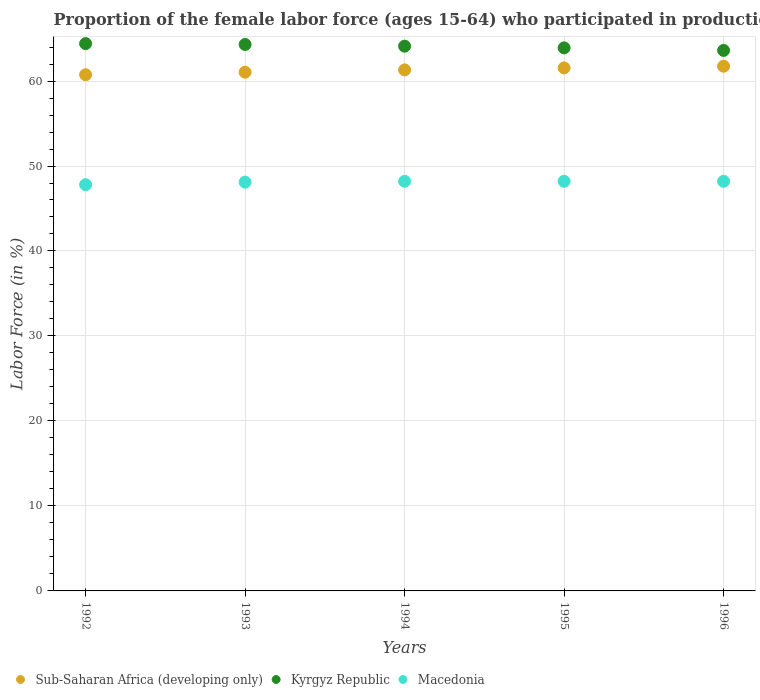What is the proportion of the female labor force who participated in production in Macedonia in 1996?
Keep it short and to the point. 48.2. Across all years, what is the maximum proportion of the female labor force who participated in production in Macedonia?
Offer a very short reply. 48.2. Across all years, what is the minimum proportion of the female labor force who participated in production in Macedonia?
Keep it short and to the point. 47.8. In which year was the proportion of the female labor force who participated in production in Kyrgyz Republic minimum?
Provide a succinct answer. 1996. What is the total proportion of the female labor force who participated in production in Sub-Saharan Africa (developing only) in the graph?
Offer a terse response. 306.37. What is the difference between the proportion of the female labor force who participated in production in Kyrgyz Republic in 1994 and that in 1995?
Make the answer very short. 0.2. What is the difference between the proportion of the female labor force who participated in production in Sub-Saharan Africa (developing only) in 1994 and the proportion of the female labor force who participated in production in Macedonia in 1995?
Keep it short and to the point. 13.11. What is the average proportion of the female labor force who participated in production in Sub-Saharan Africa (developing only) per year?
Provide a succinct answer. 61.27. In the year 1996, what is the difference between the proportion of the female labor force who participated in production in Sub-Saharan Africa (developing only) and proportion of the female labor force who participated in production in Kyrgyz Republic?
Your answer should be very brief. -1.86. What is the ratio of the proportion of the female labor force who participated in production in Kyrgyz Republic in 1994 to that in 1996?
Make the answer very short. 1.01. Is the difference between the proportion of the female labor force who participated in production in Sub-Saharan Africa (developing only) in 1992 and 1993 greater than the difference between the proportion of the female labor force who participated in production in Kyrgyz Republic in 1992 and 1993?
Provide a succinct answer. No. What is the difference between the highest and the second highest proportion of the female labor force who participated in production in Kyrgyz Republic?
Ensure brevity in your answer.  0.1. What is the difference between the highest and the lowest proportion of the female labor force who participated in production in Macedonia?
Keep it short and to the point. 0.4. In how many years, is the proportion of the female labor force who participated in production in Sub-Saharan Africa (developing only) greater than the average proportion of the female labor force who participated in production in Sub-Saharan Africa (developing only) taken over all years?
Your answer should be very brief. 3. Is it the case that in every year, the sum of the proportion of the female labor force who participated in production in Macedonia and proportion of the female labor force who participated in production in Kyrgyz Republic  is greater than the proportion of the female labor force who participated in production in Sub-Saharan Africa (developing only)?
Your response must be concise. Yes. How many years are there in the graph?
Ensure brevity in your answer.  5. What is the difference between two consecutive major ticks on the Y-axis?
Offer a very short reply. 10. Does the graph contain any zero values?
Offer a terse response. No. Where does the legend appear in the graph?
Your answer should be compact. Bottom left. What is the title of the graph?
Your answer should be compact. Proportion of the female labor force (ages 15-64) who participated in production. Does "Vietnam" appear as one of the legend labels in the graph?
Your answer should be compact. No. What is the label or title of the Y-axis?
Make the answer very short. Labor Force (in %). What is the Labor Force (in %) in Sub-Saharan Africa (developing only) in 1992?
Provide a short and direct response. 60.74. What is the Labor Force (in %) of Kyrgyz Republic in 1992?
Make the answer very short. 64.4. What is the Labor Force (in %) in Macedonia in 1992?
Keep it short and to the point. 47.8. What is the Labor Force (in %) in Sub-Saharan Africa (developing only) in 1993?
Your answer should be very brief. 61.04. What is the Labor Force (in %) in Kyrgyz Republic in 1993?
Your response must be concise. 64.3. What is the Labor Force (in %) in Macedonia in 1993?
Make the answer very short. 48.1. What is the Labor Force (in %) of Sub-Saharan Africa (developing only) in 1994?
Provide a succinct answer. 61.31. What is the Labor Force (in %) of Kyrgyz Republic in 1994?
Your answer should be very brief. 64.1. What is the Labor Force (in %) in Macedonia in 1994?
Your answer should be very brief. 48.2. What is the Labor Force (in %) of Sub-Saharan Africa (developing only) in 1995?
Provide a succinct answer. 61.54. What is the Labor Force (in %) in Kyrgyz Republic in 1995?
Your answer should be compact. 63.9. What is the Labor Force (in %) of Macedonia in 1995?
Make the answer very short. 48.2. What is the Labor Force (in %) in Sub-Saharan Africa (developing only) in 1996?
Ensure brevity in your answer.  61.74. What is the Labor Force (in %) of Kyrgyz Republic in 1996?
Offer a terse response. 63.6. What is the Labor Force (in %) in Macedonia in 1996?
Keep it short and to the point. 48.2. Across all years, what is the maximum Labor Force (in %) of Sub-Saharan Africa (developing only)?
Provide a succinct answer. 61.74. Across all years, what is the maximum Labor Force (in %) of Kyrgyz Republic?
Keep it short and to the point. 64.4. Across all years, what is the maximum Labor Force (in %) in Macedonia?
Provide a short and direct response. 48.2. Across all years, what is the minimum Labor Force (in %) of Sub-Saharan Africa (developing only)?
Give a very brief answer. 60.74. Across all years, what is the minimum Labor Force (in %) in Kyrgyz Republic?
Provide a short and direct response. 63.6. Across all years, what is the minimum Labor Force (in %) of Macedonia?
Give a very brief answer. 47.8. What is the total Labor Force (in %) in Sub-Saharan Africa (developing only) in the graph?
Ensure brevity in your answer.  306.37. What is the total Labor Force (in %) in Kyrgyz Republic in the graph?
Your response must be concise. 320.3. What is the total Labor Force (in %) of Macedonia in the graph?
Keep it short and to the point. 240.5. What is the difference between the Labor Force (in %) of Sub-Saharan Africa (developing only) in 1992 and that in 1993?
Give a very brief answer. -0.3. What is the difference between the Labor Force (in %) in Sub-Saharan Africa (developing only) in 1992 and that in 1994?
Provide a short and direct response. -0.57. What is the difference between the Labor Force (in %) of Kyrgyz Republic in 1992 and that in 1994?
Give a very brief answer. 0.3. What is the difference between the Labor Force (in %) of Sub-Saharan Africa (developing only) in 1992 and that in 1995?
Give a very brief answer. -0.8. What is the difference between the Labor Force (in %) in Sub-Saharan Africa (developing only) in 1992 and that in 1996?
Offer a very short reply. -1. What is the difference between the Labor Force (in %) in Macedonia in 1992 and that in 1996?
Your response must be concise. -0.4. What is the difference between the Labor Force (in %) of Sub-Saharan Africa (developing only) in 1993 and that in 1994?
Your response must be concise. -0.27. What is the difference between the Labor Force (in %) in Kyrgyz Republic in 1993 and that in 1994?
Make the answer very short. 0.2. What is the difference between the Labor Force (in %) in Macedonia in 1993 and that in 1994?
Ensure brevity in your answer.  -0.1. What is the difference between the Labor Force (in %) of Sub-Saharan Africa (developing only) in 1993 and that in 1995?
Offer a terse response. -0.5. What is the difference between the Labor Force (in %) in Kyrgyz Republic in 1993 and that in 1995?
Your response must be concise. 0.4. What is the difference between the Labor Force (in %) in Sub-Saharan Africa (developing only) in 1993 and that in 1996?
Give a very brief answer. -0.7. What is the difference between the Labor Force (in %) in Sub-Saharan Africa (developing only) in 1994 and that in 1995?
Your answer should be very brief. -0.23. What is the difference between the Labor Force (in %) in Kyrgyz Republic in 1994 and that in 1995?
Keep it short and to the point. 0.2. What is the difference between the Labor Force (in %) in Macedonia in 1994 and that in 1995?
Your response must be concise. 0. What is the difference between the Labor Force (in %) in Sub-Saharan Africa (developing only) in 1994 and that in 1996?
Make the answer very short. -0.43. What is the difference between the Labor Force (in %) in Kyrgyz Republic in 1994 and that in 1996?
Offer a very short reply. 0.5. What is the difference between the Labor Force (in %) of Macedonia in 1994 and that in 1996?
Give a very brief answer. 0. What is the difference between the Labor Force (in %) of Sub-Saharan Africa (developing only) in 1995 and that in 1996?
Your response must be concise. -0.2. What is the difference between the Labor Force (in %) of Kyrgyz Republic in 1995 and that in 1996?
Your response must be concise. 0.3. What is the difference between the Labor Force (in %) of Sub-Saharan Africa (developing only) in 1992 and the Labor Force (in %) of Kyrgyz Republic in 1993?
Provide a succinct answer. -3.56. What is the difference between the Labor Force (in %) in Sub-Saharan Africa (developing only) in 1992 and the Labor Force (in %) in Macedonia in 1993?
Give a very brief answer. 12.64. What is the difference between the Labor Force (in %) of Kyrgyz Republic in 1992 and the Labor Force (in %) of Macedonia in 1993?
Offer a terse response. 16.3. What is the difference between the Labor Force (in %) of Sub-Saharan Africa (developing only) in 1992 and the Labor Force (in %) of Kyrgyz Republic in 1994?
Offer a very short reply. -3.36. What is the difference between the Labor Force (in %) in Sub-Saharan Africa (developing only) in 1992 and the Labor Force (in %) in Macedonia in 1994?
Your response must be concise. 12.54. What is the difference between the Labor Force (in %) of Kyrgyz Republic in 1992 and the Labor Force (in %) of Macedonia in 1994?
Your response must be concise. 16.2. What is the difference between the Labor Force (in %) of Sub-Saharan Africa (developing only) in 1992 and the Labor Force (in %) of Kyrgyz Republic in 1995?
Offer a very short reply. -3.16. What is the difference between the Labor Force (in %) of Sub-Saharan Africa (developing only) in 1992 and the Labor Force (in %) of Macedonia in 1995?
Your answer should be very brief. 12.54. What is the difference between the Labor Force (in %) in Kyrgyz Republic in 1992 and the Labor Force (in %) in Macedonia in 1995?
Your answer should be compact. 16.2. What is the difference between the Labor Force (in %) in Sub-Saharan Africa (developing only) in 1992 and the Labor Force (in %) in Kyrgyz Republic in 1996?
Give a very brief answer. -2.86. What is the difference between the Labor Force (in %) in Sub-Saharan Africa (developing only) in 1992 and the Labor Force (in %) in Macedonia in 1996?
Offer a terse response. 12.54. What is the difference between the Labor Force (in %) in Sub-Saharan Africa (developing only) in 1993 and the Labor Force (in %) in Kyrgyz Republic in 1994?
Make the answer very short. -3.06. What is the difference between the Labor Force (in %) in Sub-Saharan Africa (developing only) in 1993 and the Labor Force (in %) in Macedonia in 1994?
Your response must be concise. 12.84. What is the difference between the Labor Force (in %) of Kyrgyz Republic in 1993 and the Labor Force (in %) of Macedonia in 1994?
Your response must be concise. 16.1. What is the difference between the Labor Force (in %) of Sub-Saharan Africa (developing only) in 1993 and the Labor Force (in %) of Kyrgyz Republic in 1995?
Your answer should be very brief. -2.86. What is the difference between the Labor Force (in %) of Sub-Saharan Africa (developing only) in 1993 and the Labor Force (in %) of Macedonia in 1995?
Your answer should be very brief. 12.84. What is the difference between the Labor Force (in %) in Sub-Saharan Africa (developing only) in 1993 and the Labor Force (in %) in Kyrgyz Republic in 1996?
Your answer should be very brief. -2.56. What is the difference between the Labor Force (in %) of Sub-Saharan Africa (developing only) in 1993 and the Labor Force (in %) of Macedonia in 1996?
Offer a very short reply. 12.84. What is the difference between the Labor Force (in %) of Sub-Saharan Africa (developing only) in 1994 and the Labor Force (in %) of Kyrgyz Republic in 1995?
Your answer should be very brief. -2.59. What is the difference between the Labor Force (in %) of Sub-Saharan Africa (developing only) in 1994 and the Labor Force (in %) of Macedonia in 1995?
Keep it short and to the point. 13.11. What is the difference between the Labor Force (in %) in Kyrgyz Republic in 1994 and the Labor Force (in %) in Macedonia in 1995?
Your response must be concise. 15.9. What is the difference between the Labor Force (in %) of Sub-Saharan Africa (developing only) in 1994 and the Labor Force (in %) of Kyrgyz Republic in 1996?
Offer a very short reply. -2.29. What is the difference between the Labor Force (in %) in Sub-Saharan Africa (developing only) in 1994 and the Labor Force (in %) in Macedonia in 1996?
Your answer should be compact. 13.11. What is the difference between the Labor Force (in %) of Sub-Saharan Africa (developing only) in 1995 and the Labor Force (in %) of Kyrgyz Republic in 1996?
Offer a very short reply. -2.06. What is the difference between the Labor Force (in %) in Sub-Saharan Africa (developing only) in 1995 and the Labor Force (in %) in Macedonia in 1996?
Your response must be concise. 13.34. What is the difference between the Labor Force (in %) of Kyrgyz Republic in 1995 and the Labor Force (in %) of Macedonia in 1996?
Provide a succinct answer. 15.7. What is the average Labor Force (in %) of Sub-Saharan Africa (developing only) per year?
Your answer should be very brief. 61.27. What is the average Labor Force (in %) in Kyrgyz Republic per year?
Your response must be concise. 64.06. What is the average Labor Force (in %) in Macedonia per year?
Ensure brevity in your answer.  48.1. In the year 1992, what is the difference between the Labor Force (in %) of Sub-Saharan Africa (developing only) and Labor Force (in %) of Kyrgyz Republic?
Offer a terse response. -3.66. In the year 1992, what is the difference between the Labor Force (in %) of Sub-Saharan Africa (developing only) and Labor Force (in %) of Macedonia?
Ensure brevity in your answer.  12.94. In the year 1992, what is the difference between the Labor Force (in %) in Kyrgyz Republic and Labor Force (in %) in Macedonia?
Offer a terse response. 16.6. In the year 1993, what is the difference between the Labor Force (in %) in Sub-Saharan Africa (developing only) and Labor Force (in %) in Kyrgyz Republic?
Offer a terse response. -3.26. In the year 1993, what is the difference between the Labor Force (in %) of Sub-Saharan Africa (developing only) and Labor Force (in %) of Macedonia?
Offer a very short reply. 12.94. In the year 1994, what is the difference between the Labor Force (in %) of Sub-Saharan Africa (developing only) and Labor Force (in %) of Kyrgyz Republic?
Ensure brevity in your answer.  -2.79. In the year 1994, what is the difference between the Labor Force (in %) in Sub-Saharan Africa (developing only) and Labor Force (in %) in Macedonia?
Offer a terse response. 13.11. In the year 1994, what is the difference between the Labor Force (in %) of Kyrgyz Republic and Labor Force (in %) of Macedonia?
Provide a succinct answer. 15.9. In the year 1995, what is the difference between the Labor Force (in %) of Sub-Saharan Africa (developing only) and Labor Force (in %) of Kyrgyz Republic?
Make the answer very short. -2.36. In the year 1995, what is the difference between the Labor Force (in %) of Sub-Saharan Africa (developing only) and Labor Force (in %) of Macedonia?
Your answer should be compact. 13.34. In the year 1996, what is the difference between the Labor Force (in %) in Sub-Saharan Africa (developing only) and Labor Force (in %) in Kyrgyz Republic?
Keep it short and to the point. -1.86. In the year 1996, what is the difference between the Labor Force (in %) of Sub-Saharan Africa (developing only) and Labor Force (in %) of Macedonia?
Your response must be concise. 13.54. What is the ratio of the Labor Force (in %) of Kyrgyz Republic in 1992 to that in 1993?
Keep it short and to the point. 1. What is the ratio of the Labor Force (in %) of Sub-Saharan Africa (developing only) in 1992 to that in 1995?
Keep it short and to the point. 0.99. What is the ratio of the Labor Force (in %) in Sub-Saharan Africa (developing only) in 1992 to that in 1996?
Make the answer very short. 0.98. What is the ratio of the Labor Force (in %) of Kyrgyz Republic in 1992 to that in 1996?
Ensure brevity in your answer.  1.01. What is the ratio of the Labor Force (in %) of Sub-Saharan Africa (developing only) in 1993 to that in 1994?
Your response must be concise. 1. What is the ratio of the Labor Force (in %) of Sub-Saharan Africa (developing only) in 1993 to that in 1995?
Offer a very short reply. 0.99. What is the ratio of the Labor Force (in %) in Kyrgyz Republic in 1993 to that in 1995?
Provide a short and direct response. 1.01. What is the ratio of the Labor Force (in %) of Macedonia in 1993 to that in 1996?
Your answer should be compact. 1. What is the ratio of the Labor Force (in %) in Kyrgyz Republic in 1994 to that in 1995?
Offer a terse response. 1. What is the ratio of the Labor Force (in %) in Macedonia in 1994 to that in 1995?
Provide a short and direct response. 1. What is the ratio of the Labor Force (in %) in Sub-Saharan Africa (developing only) in 1994 to that in 1996?
Make the answer very short. 0.99. What is the ratio of the Labor Force (in %) of Kyrgyz Republic in 1994 to that in 1996?
Your answer should be compact. 1.01. What is the ratio of the Labor Force (in %) in Macedonia in 1994 to that in 1996?
Your answer should be very brief. 1. What is the ratio of the Labor Force (in %) of Kyrgyz Republic in 1995 to that in 1996?
Offer a terse response. 1. What is the ratio of the Labor Force (in %) of Macedonia in 1995 to that in 1996?
Offer a terse response. 1. What is the difference between the highest and the second highest Labor Force (in %) of Sub-Saharan Africa (developing only)?
Give a very brief answer. 0.2. What is the difference between the highest and the second highest Labor Force (in %) of Kyrgyz Republic?
Ensure brevity in your answer.  0.1. What is the difference between the highest and the second highest Labor Force (in %) of Macedonia?
Provide a succinct answer. 0. What is the difference between the highest and the lowest Labor Force (in %) of Macedonia?
Make the answer very short. 0.4. 